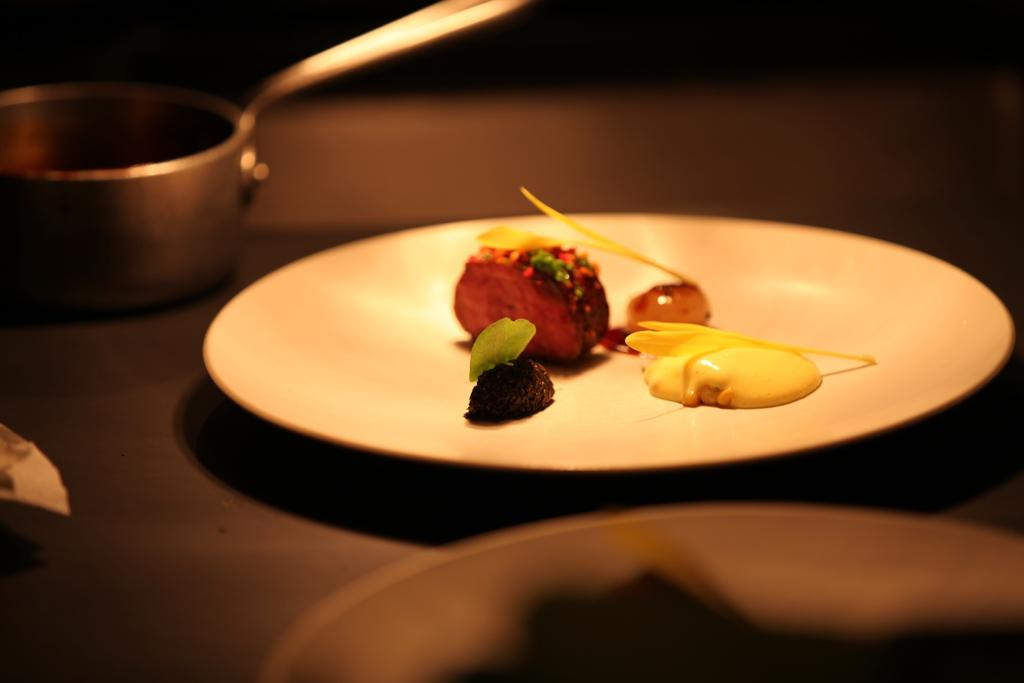What is the main piece of furniture in the image? There is a table in the image. How many plates are placed on the table? Two plates are placed on the table. What else is placed on the table besides the plates? A bowl is placed on the table. What can be found on the plates? There are food items on the plates. What type of fuel is being used to heat the food on the plates? There is no indication of any fuel or heating source in the image; the food items are already on the plates. 